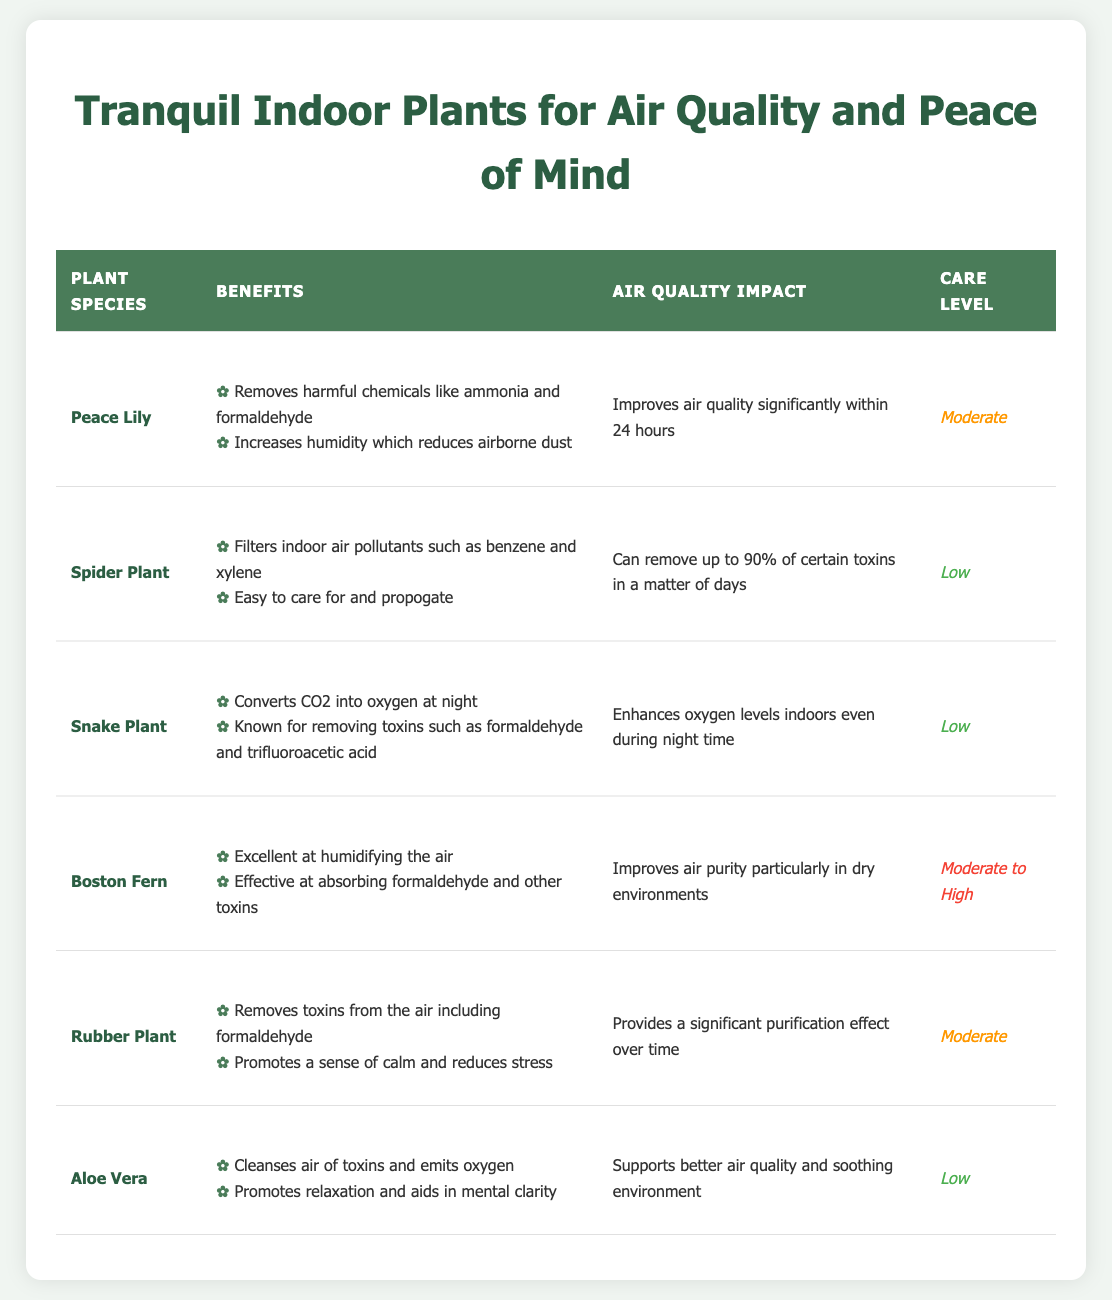What benefits does the Peace Lily provide? The table indicates that the Peace Lily removes harmful chemicals like ammonia and formaldehyde and increases humidity, which reduces airborne dust.
Answer: Removes harmful chemicals and increases humidity Which indoor plant has the highest air quality impact? The Spider Plant can remove up to 90% of certain toxins in a matter of days, which indicates it has the highest immediate air quality impact compared to others listed.
Answer: Spider Plant Is the Snake Plant easy to care for? The care level for the Snake Plant is listed as Low, which means it is easy to care for.
Answer: Yes Which plants promote relaxation? The table shows that the Rubber Plant and Aloe Vera both promote relaxation; hence, these two species are known for this benefit.
Answer: Rubber Plant and Aloe Vera What is the average care level for the plants listed? There are six plants with varying care levels: 2 low (Spider Plant, Snake Plant, Aloe Vera), 2 moderate (Peace Lily, Rubber Plant), and 2 moderate to high (Boston Fern), the average is roughly 1.33 meaning the care level can be considered moderate.
Answer: Moderate Do all listed plants improve air quality within 24 hours? Not all plants specify improvements within 24 hours; only the Peace Lily is noted to improve air quality significantly in this time frame while others indicate improvements over different times.
Answer: No Which plants are effective at absorbing formaldehyde? The Peace Lily, Snake Plant, Boston Fern, and Rubber Plant are all mentioned as effective at absorbing formaldehyde, requiring the person to check the benefits column for confirmation.
Answer: Peace Lily, Snake Plant, Boston Fern, Rubber Plant What is the care level difference between the Boston Fern and the Aloe Vera? The Boston Fern has a care level of Moderate to High, while the Aloe Vera has a Low care level; thus, the Boston Fern requires more attention compared to Aloe Vera.
Answer: Moderate to High vs. Low 